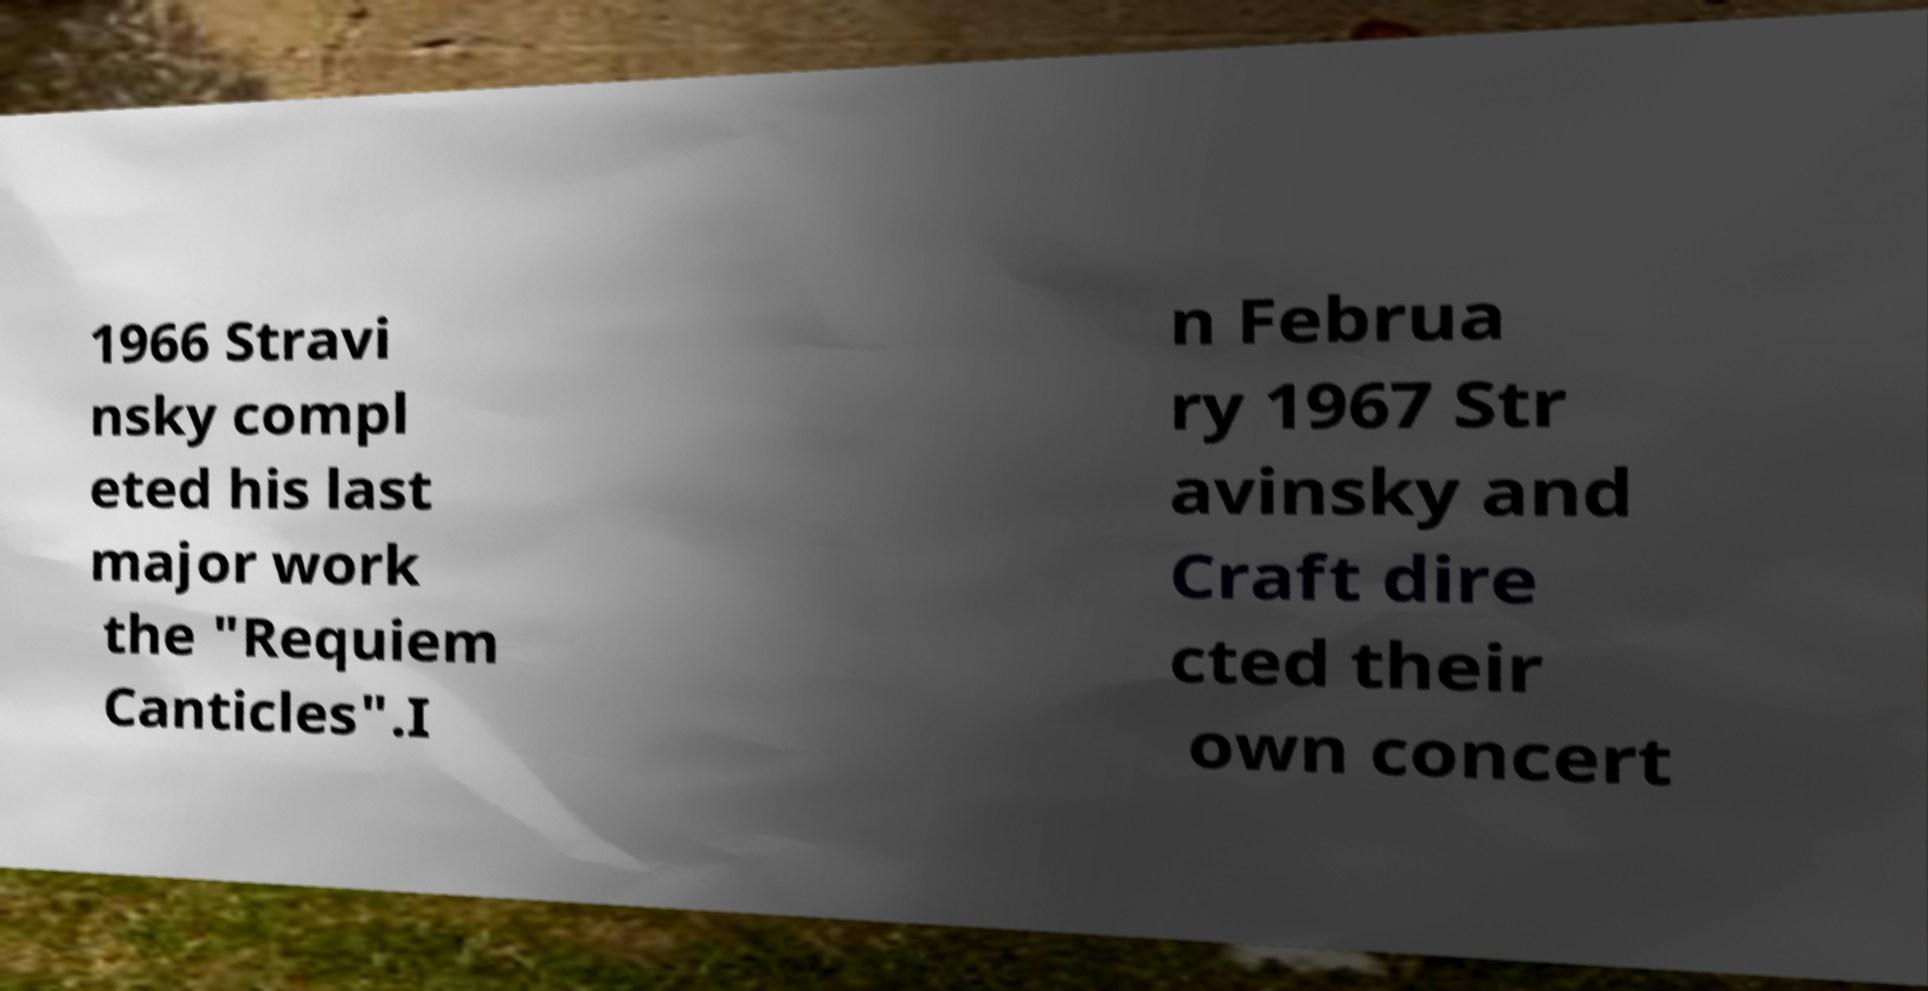Can you read and provide the text displayed in the image?This photo seems to have some interesting text. Can you extract and type it out for me? 1966 Stravi nsky compl eted his last major work the "Requiem Canticles".I n Februa ry 1967 Str avinsky and Craft dire cted their own concert 